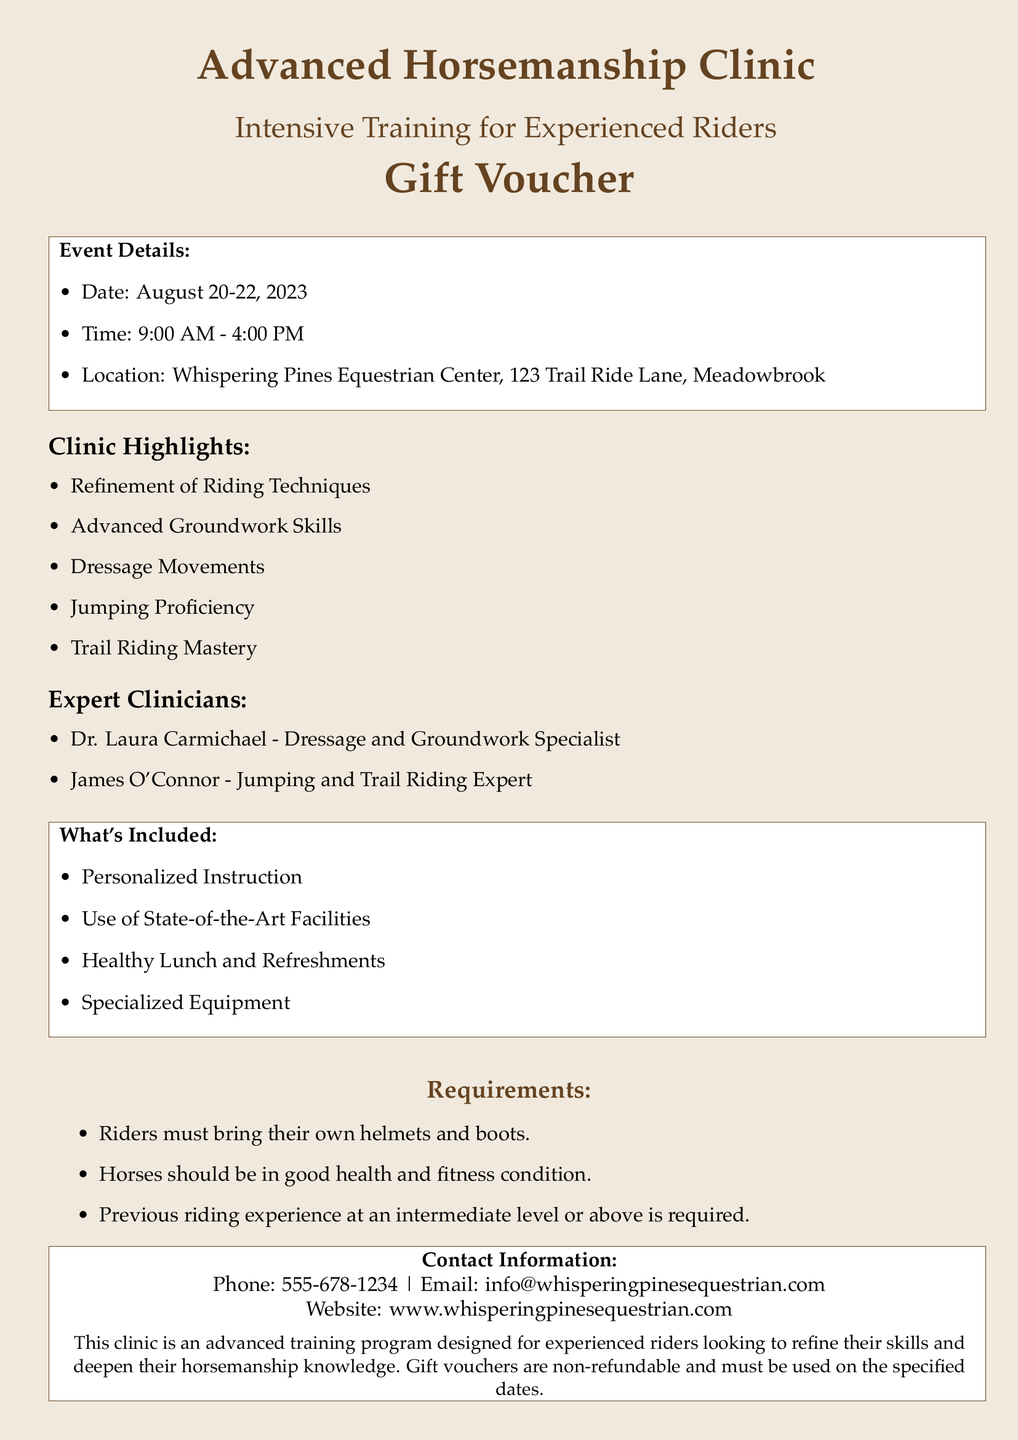What are the dates of the clinic? The document provides the schedule for the clinic, which is August 20-22, 2023.
Answer: August 20-22, 2023 What is the location of the clinic? The clinic's location is specified as Whispering Pines Equestrian Center, 123 Trail Ride Lane, Meadowbrook.
Answer: Whispering Pines Equestrian Center, 123 Trail Ride Lane, Meadowbrook Who are the expert clinicians? The document lists two expert clinicians: Dr. Laura Carmichael and James O'Connor.
Answer: Dr. Laura Carmichael and James O'Connor What is included in the clinic? The document outlines several items included in the clinic, such as personalized instruction, use of facilities, and lunch.
Answer: Personalized Instruction, Use of State-of-the-Art Facilities, Healthy Lunch and Refreshments, Specialized Equipment What are the requirements for riders? The document specifies that riders must bring their own helmets, boots, and have previous riding experience.
Answer: Riders must bring their own helmets and boots; previous riding experience required 